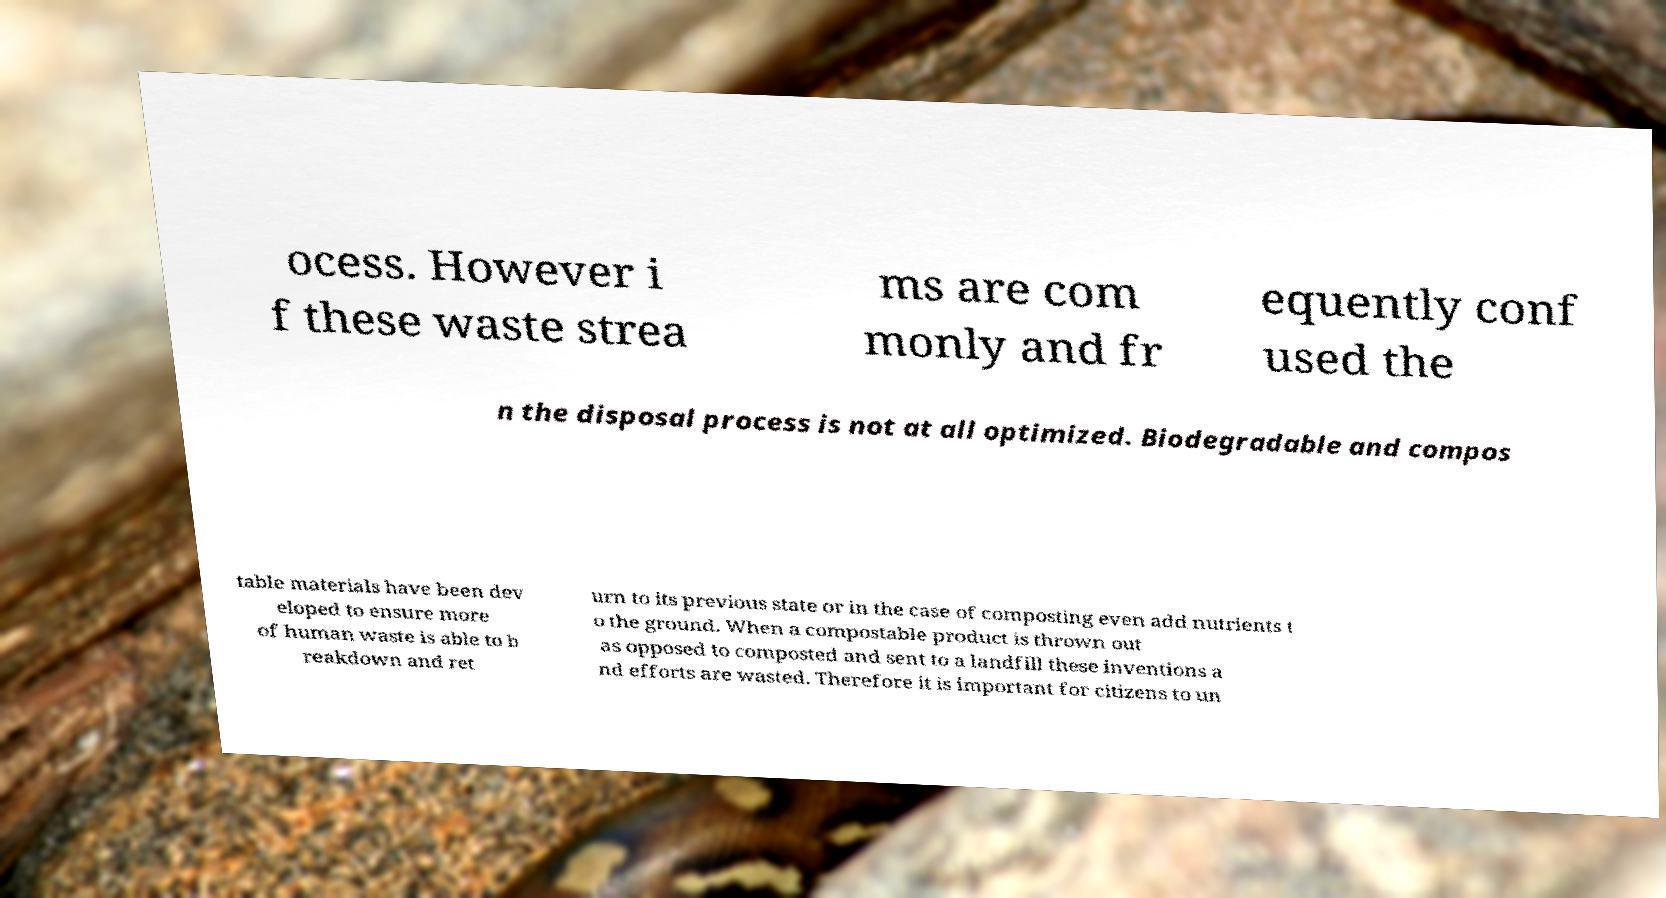Could you extract and type out the text from this image? ocess. However i f these waste strea ms are com monly and fr equently conf used the n the disposal process is not at all optimized. Biodegradable and compos table materials have been dev eloped to ensure more of human waste is able to b reakdown and ret urn to its previous state or in the case of composting even add nutrients t o the ground. When a compostable product is thrown out as opposed to composted and sent to a landfill these inventions a nd efforts are wasted. Therefore it is important for citizens to un 